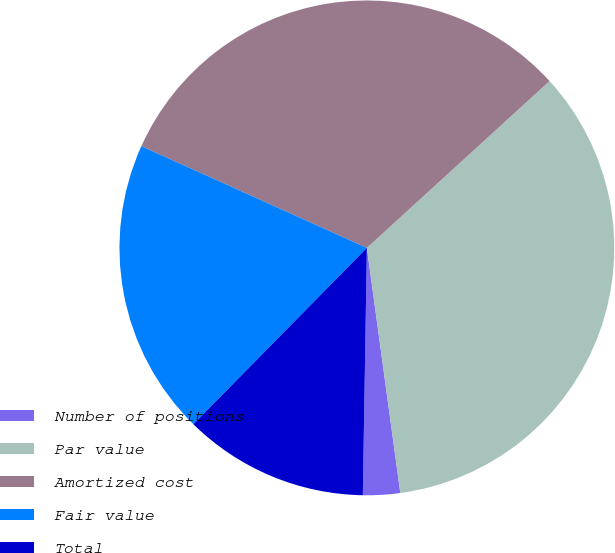Convert chart to OTSL. <chart><loc_0><loc_0><loc_500><loc_500><pie_chart><fcel>Number of positions<fcel>Par value<fcel>Amortized cost<fcel>Fair value<fcel>Total<nl><fcel>2.42%<fcel>34.62%<fcel>31.48%<fcel>19.37%<fcel>12.11%<nl></chart> 